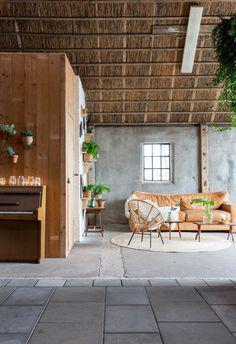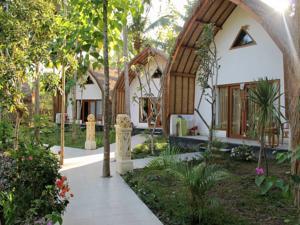The first image is the image on the left, the second image is the image on the right. For the images displayed, is the sentence "Both images are inside." factually correct? Answer yes or no. No. The first image is the image on the left, the second image is the image on the right. Assess this claim about the two images: "The left and right image contains both an external view of the building and internal view of a resort.". Correct or not? Answer yes or no. Yes. 